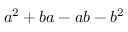Convert formula to latex. <formula><loc_0><loc_0><loc_500><loc_500>a ^ { 2 } + b a - a b - b ^ { 2 }</formula> 